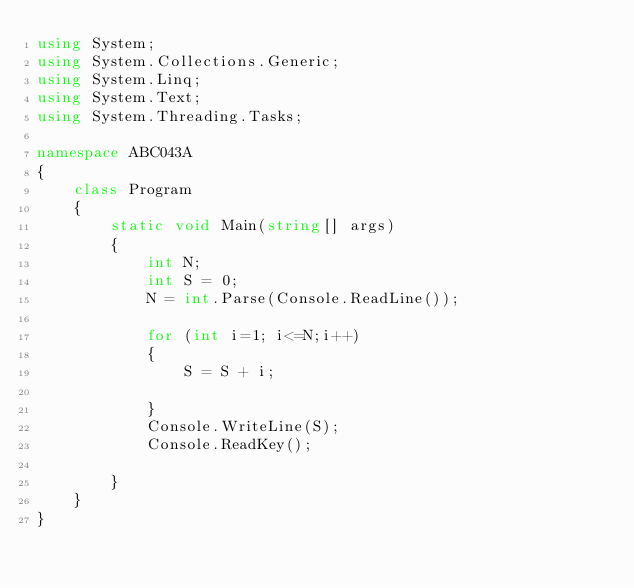Convert code to text. <code><loc_0><loc_0><loc_500><loc_500><_C#_>using System;
using System.Collections.Generic;
using System.Linq;
using System.Text;
using System.Threading.Tasks;

namespace ABC043A
{
    class Program
    {
        static void Main(string[] args)
        {
            int N;
            int S = 0;
            N = int.Parse(Console.ReadLine());

            for (int i=1; i<=N;i++)
            {
                S = S + i;

            }
            Console.WriteLine(S);
            Console.ReadKey();

        }
    }
}
</code> 